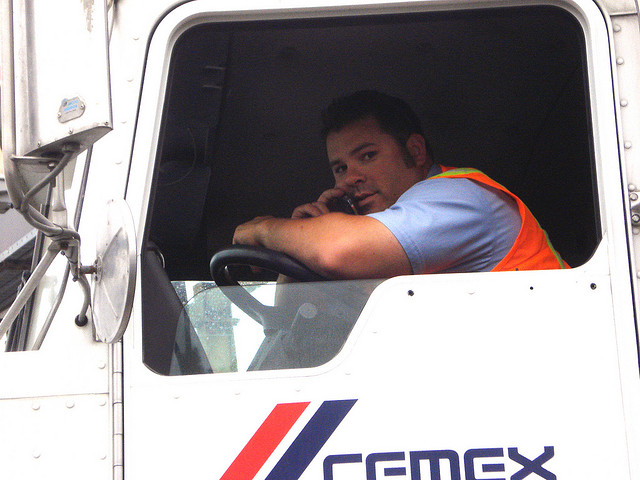Please identify all text content in this image. CEMEX 